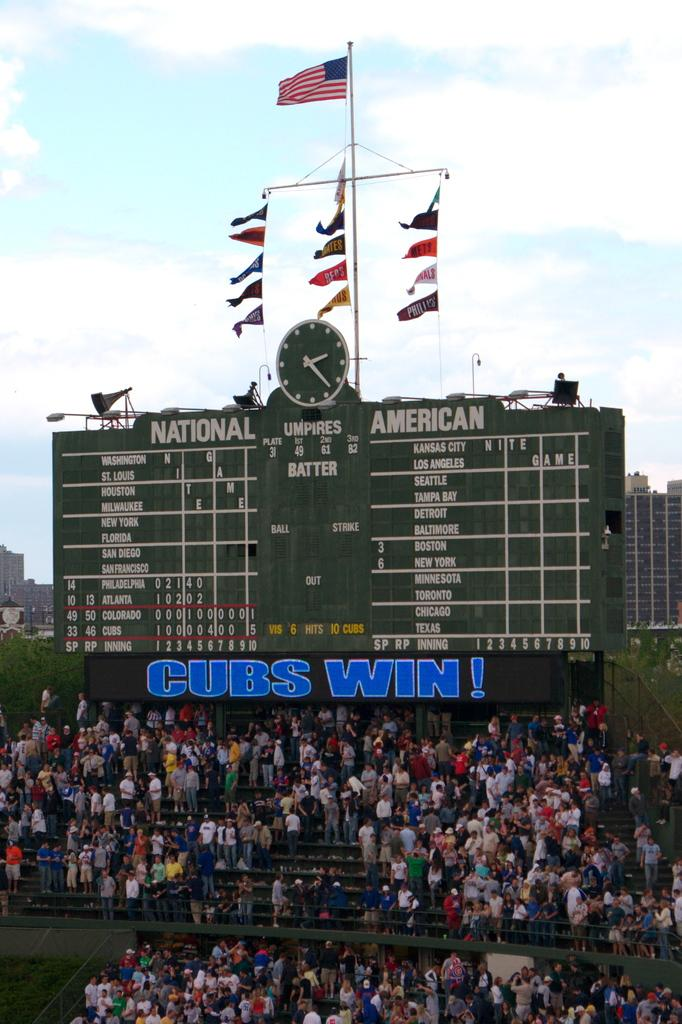<image>
Offer a succinct explanation of the picture presented. a Cubs Win name that is on a scoreboard 